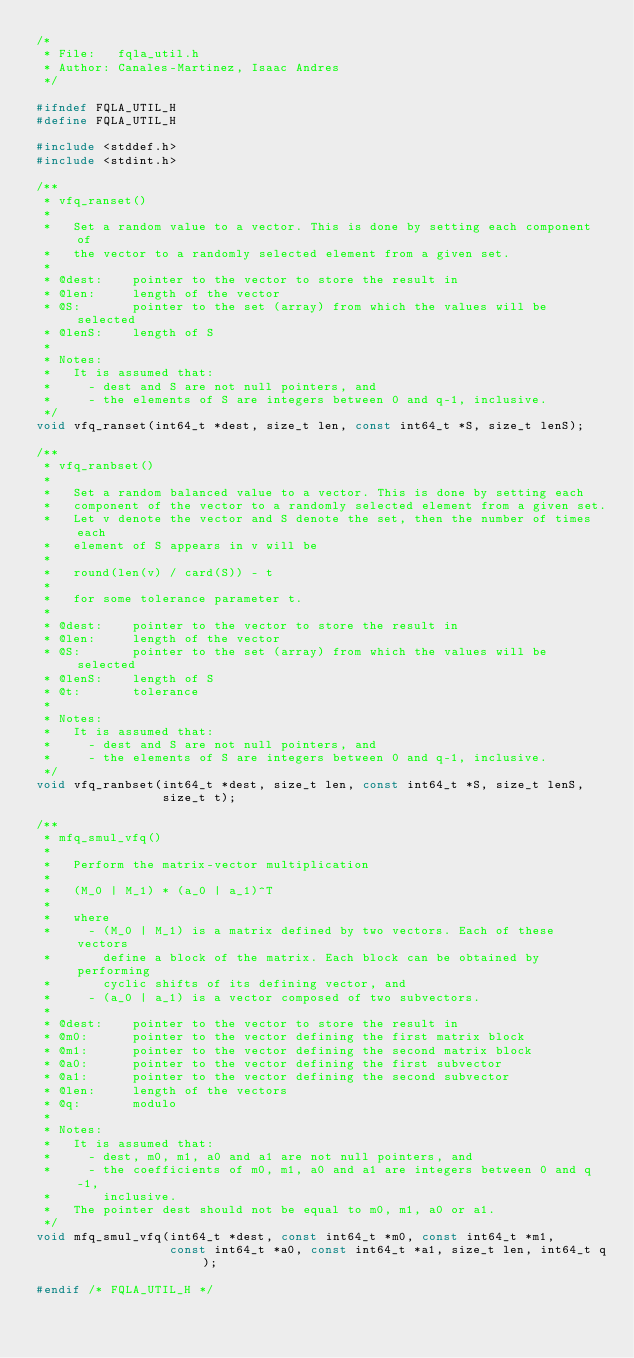Convert code to text. <code><loc_0><loc_0><loc_500><loc_500><_C_>/*
 * File:   fqla_util.h
 * Author: Canales-Martinez, Isaac Andres
 */

#ifndef FQLA_UTIL_H
#define FQLA_UTIL_H

#include <stddef.h>
#include <stdint.h>

/**
 * vfq_ranset()
 *
 *   Set a random value to a vector. This is done by setting each component of
 *   the vector to a randomly selected element from a given set.
 *
 * @dest:    pointer to the vector to store the result in
 * @len:     length of the vector
 * @S:       pointer to the set (array) from which the values will be selected
 * @lenS:    length of S
 *
 * Notes:
 *   It is assumed that:
 *     - dest and S are not null pointers, and
 *     - the elements of S are integers between 0 and q-1, inclusive.
 */
void vfq_ranset(int64_t *dest, size_t len, const int64_t *S, size_t lenS);

/**
 * vfq_ranbset()
 *
 *   Set a random balanced value to a vector. This is done by setting each
 *   component of the vector to a randomly selected element from a given set.
 *   Let v denote the vector and S denote the set, then the number of times each
 *   element of S appears in v will be
 *
 *   round(len(v) / card(S)) - t
 *
 *   for some tolerance parameter t.
 *
 * @dest:    pointer to the vector to store the result in
 * @len:     length of the vector
 * @S:       pointer to the set (array) from which the values will be selected
 * @lenS:    length of S
 * @t:       tolerance
 *
 * Notes:
 *   It is assumed that:
 *     - dest and S are not null pointers, and
 *     - the elements of S are integers between 0 and q-1, inclusive.
 */
void vfq_ranbset(int64_t *dest, size_t len, const int64_t *S, size_t lenS,
                 size_t t);

/**
 * mfq_smul_vfq()
 *
 *   Perform the matrix-vector multiplication
 *
 *   (M_0 | M_1) * (a_0 | a_1)^T
 *
 *   where
 *     - (M_0 | M_1) is a matrix defined by two vectors. Each of these vectors
 *       define a block of the matrix. Each block can be obtained by performing
 *       cyclic shifts of its defining vector, and
 *     - (a_0 | a_1) is a vector composed of two subvectors.
 *
 * @dest:    pointer to the vector to store the result in
 * @m0:      pointer to the vector defining the first matrix block
 * @m1:      pointer to the vector defining the second matrix block
 * @a0:      pointer to the vector defining the first subvector
 * @a1:      pointer to the vector defining the second subvector
 * @len:     length of the vectors
 * @q:       modulo
 *
 * Notes:
 *   It is assumed that:
 *     - dest, m0, m1, a0 and a1 are not null pointers, and
 *     - the coefficients of m0, m1, a0 and a1 are integers between 0 and q-1,
 *       inclusive.
 *   The pointer dest should not be equal to m0, m1, a0 or a1.
 */
void mfq_smul_vfq(int64_t *dest, const int64_t *m0, const int64_t *m1,
                  const int64_t *a0, const int64_t *a1, size_t len, int64_t q);

#endif /* FQLA_UTIL_H */
</code> 